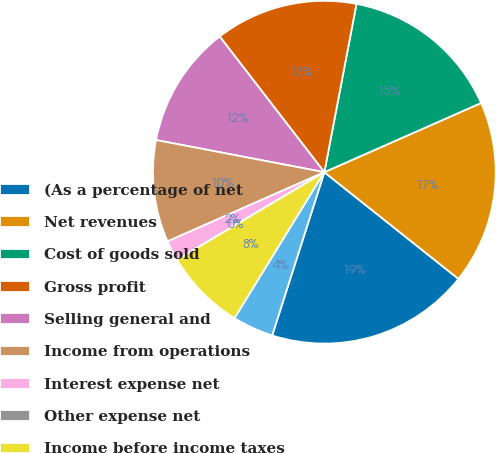Convert chart. <chart><loc_0><loc_0><loc_500><loc_500><pie_chart><fcel>(As a percentage of net<fcel>Net revenues<fcel>Cost of goods sold<fcel>Gross profit<fcel>Selling general and<fcel>Income from operations<fcel>Interest expense net<fcel>Other expense net<fcel>Income before income taxes<fcel>Provision for income taxes<nl><fcel>19.23%<fcel>17.31%<fcel>15.38%<fcel>13.46%<fcel>11.54%<fcel>9.62%<fcel>1.92%<fcel>0.0%<fcel>7.69%<fcel>3.85%<nl></chart> 